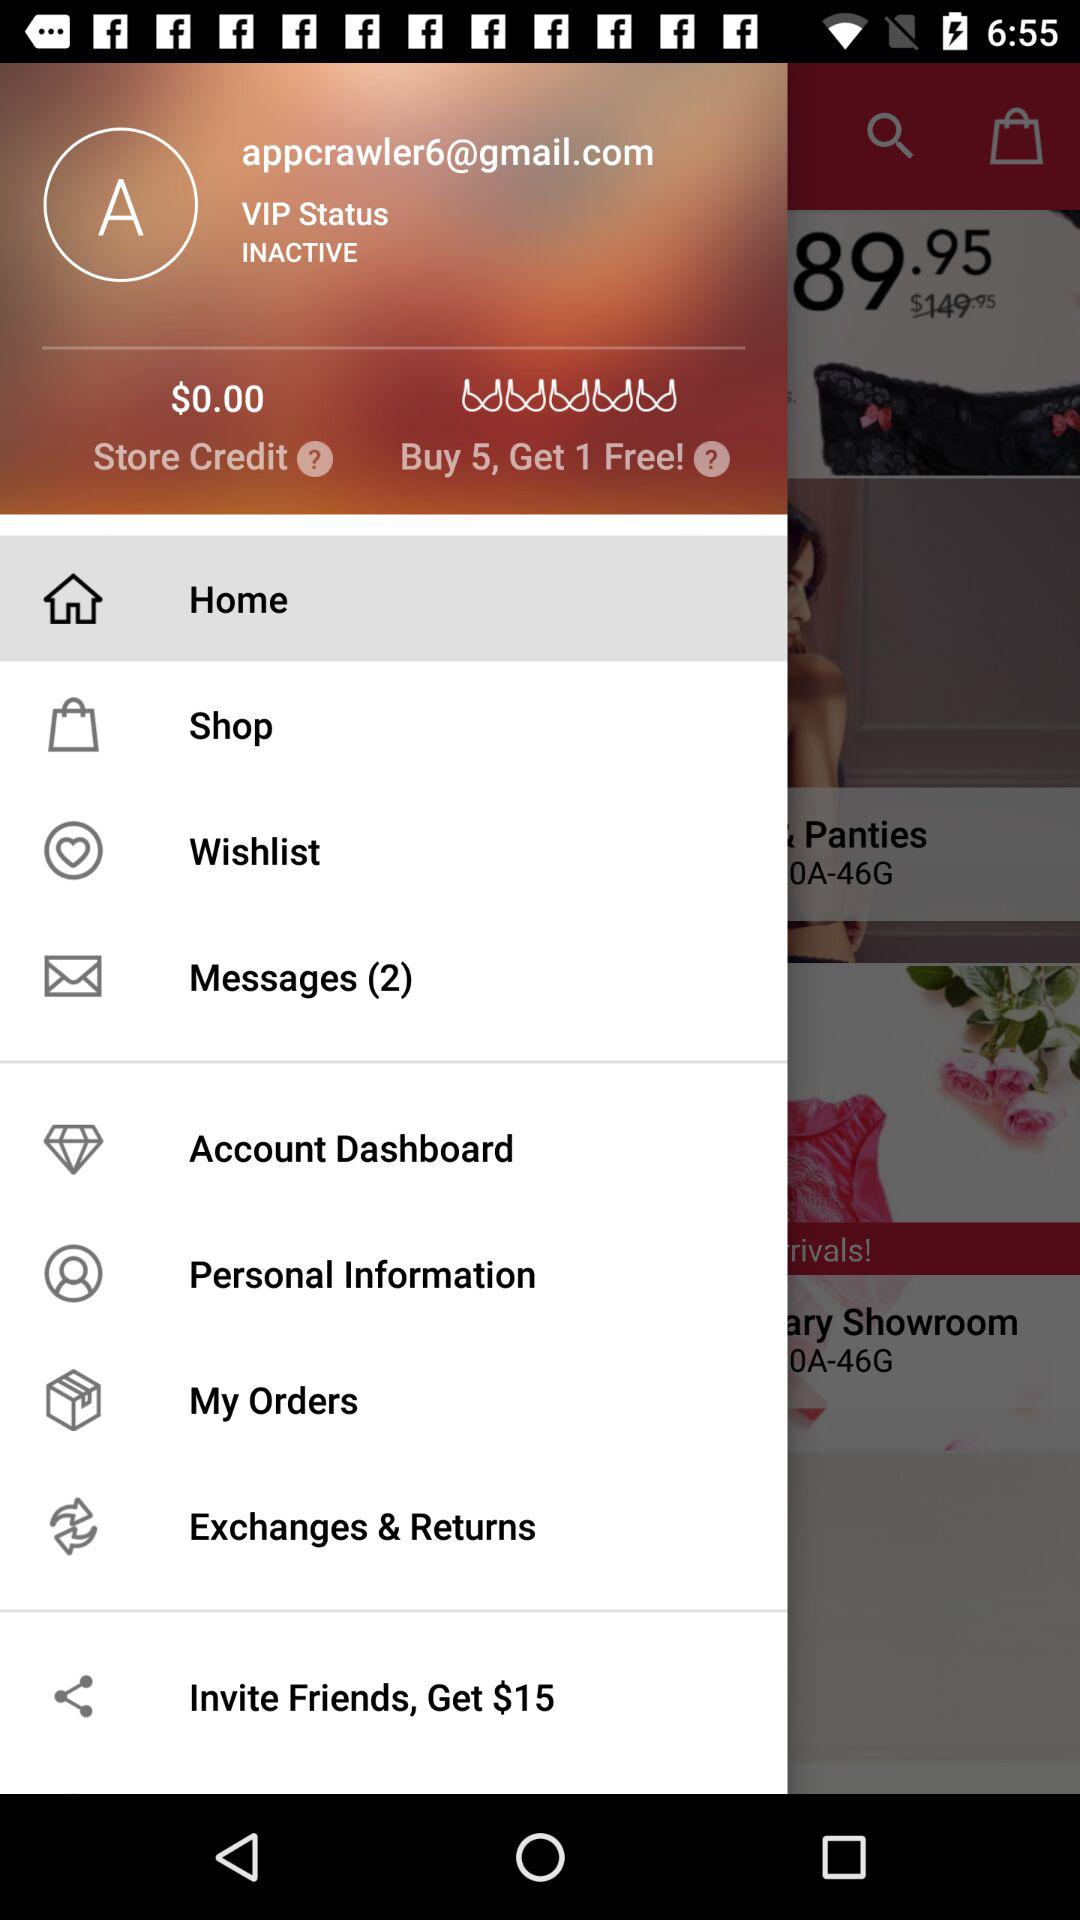How many messages are there? There are 2 messages. 